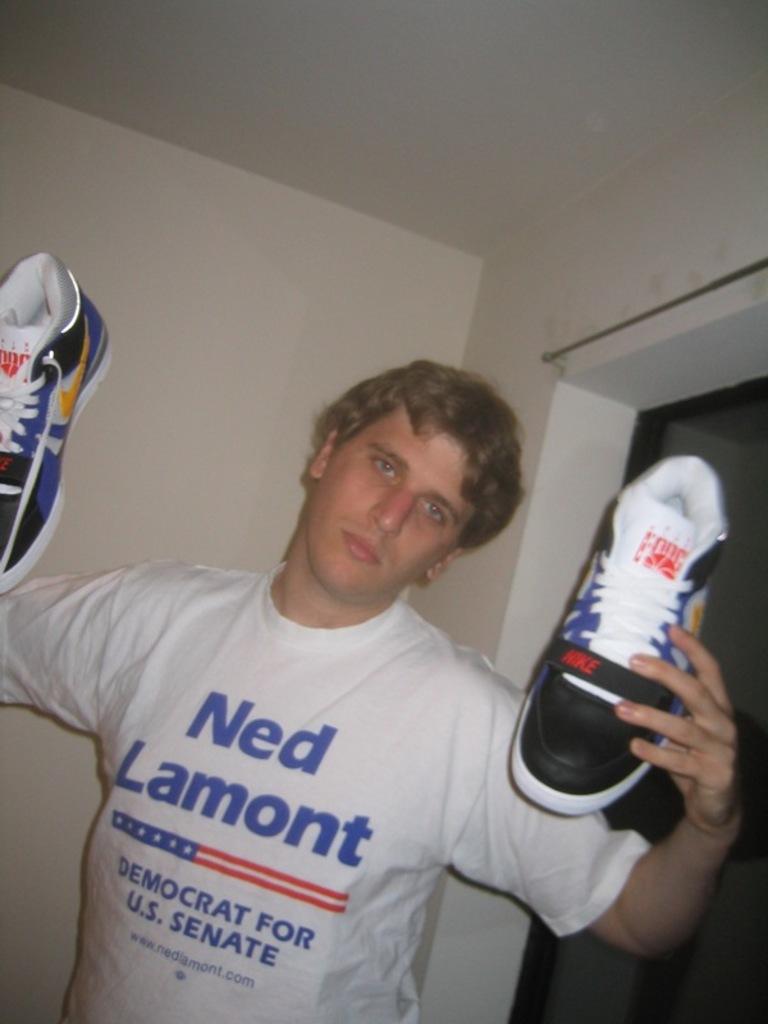Who is running for u.s. senate?
Give a very brief answer. Ned lamont. 